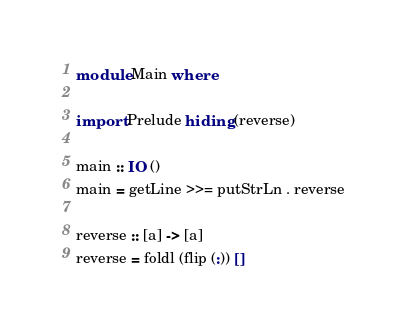Convert code to text. <code><loc_0><loc_0><loc_500><loc_500><_Haskell_>module Main where

import Prelude hiding (reverse)

main :: IO ()
main = getLine >>= putStrLn . reverse

reverse :: [a] -> [a]
reverse = foldl (flip (:)) []</code> 